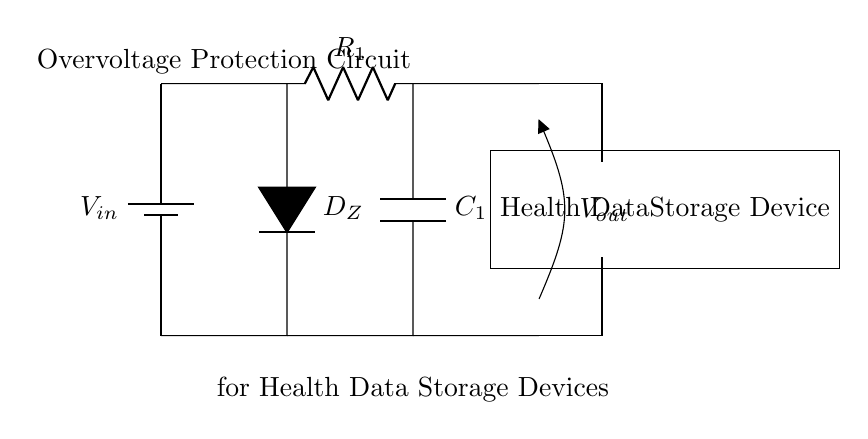What is the main purpose of this circuit? The main purpose of this circuit is to protect health data storage devices from overvoltage conditions. This is achieved using components like the Zener diode which allows voltage to clamp at a safe level.
Answer: Overvoltage protection What type of diode is used in this circuit? The circuit employs a Zener diode, which is specifically designed to allow current to flow in reverse once a specified voltage is reached, thus providing overvoltage protection.
Answer: Zener diode What components are used in the circuit? The major components utilized are a battery for input voltage, a Zener diode, a resistor, a capacitor, and a health data storage device. Each component plays a critical role in maintaining the circuit's function and protecting the device.
Answer: Battery, Zener diode, resistor, capacitor What is the connection between the Zener diode and the capacitor? The Zener diode is connected in parallel with the capacitor to ensure that when the voltage exceeds a certain threshold, the Zener diode conducts and the capacitor helps stabilize the voltage, protecting downstream devices.
Answer: Parallel connection How does this circuit protect health data storage devices from overvoltage? The Zener diode conducts when the voltage exceeds its specified breakdown voltage, shunting excess voltage away from the health data storage device, while the capacitor helps to absorb any voltage spikes, maintaining stable operation.
Answer: By clamping excess voltage What is the role of resistor R1 in this circuit? The resistor R1 limits the current through the circuit, helping to prevent excessive current that could potentially damage sensitive components like the Zener diode and the health data storage device.
Answer: Current limiting 